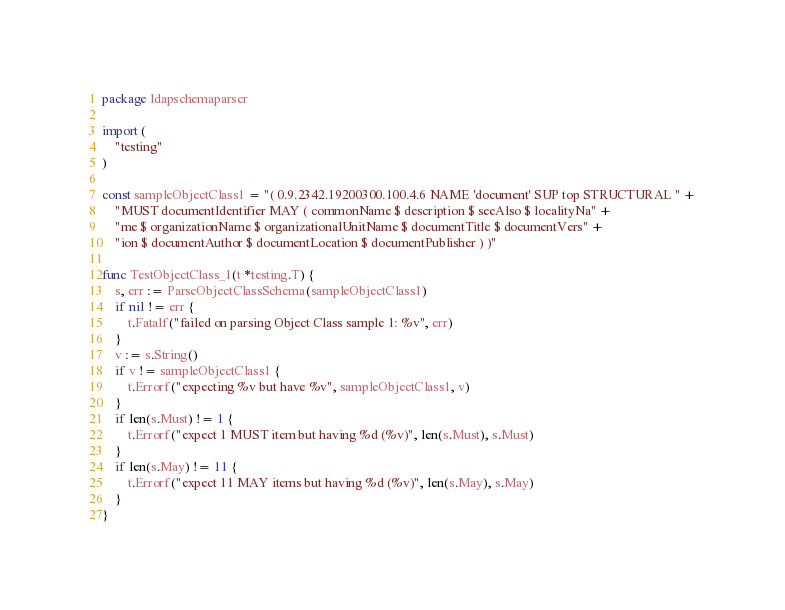Convert code to text. <code><loc_0><loc_0><loc_500><loc_500><_Go_>package ldapschemaparser

import (
	"testing"
)

const sampleObjectClass1 = "( 0.9.2342.19200300.100.4.6 NAME 'document' SUP top STRUCTURAL " +
	"MUST documentIdentifier MAY ( commonName $ description $ seeAlso $ localityNa" +
	"me $ organizationName $ organizationalUnitName $ documentTitle $ documentVers" +
	"ion $ documentAuthor $ documentLocation $ documentPublisher ) )"

func TestObjectClass_1(t *testing.T) {
	s, err := ParseObjectClassSchema(sampleObjectClass1)
	if nil != err {
		t.Fatalf("failed on parsing Object Class sample 1: %v", err)
	}
	v := s.String()
	if v != sampleObjectClass1 {
		t.Errorf("expecting %v but have %v", sampleObjectClass1, v)
	}
	if len(s.Must) != 1 {
		t.Errorf("expect 1 MUST item but having %d (%v)", len(s.Must), s.Must)
	}
	if len(s.May) != 11 {
		t.Errorf("expect 11 MAY items but having %d (%v)", len(s.May), s.May)
	}
}
</code> 